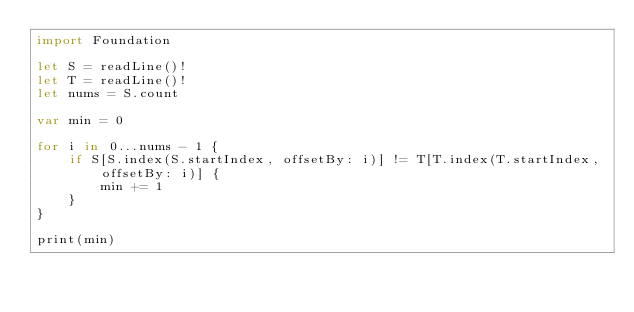<code> <loc_0><loc_0><loc_500><loc_500><_Swift_>import Foundation

let S = readLine()!
let T = readLine()!
let nums = S.count
 
var min = 0
 
for i in 0...nums - 1 {
    if S[S.index(S.startIndex, offsetBy: i)] != T[T.index(T.startIndex, offsetBy: i)] {
        min += 1
    }
}
 
print(min)</code> 